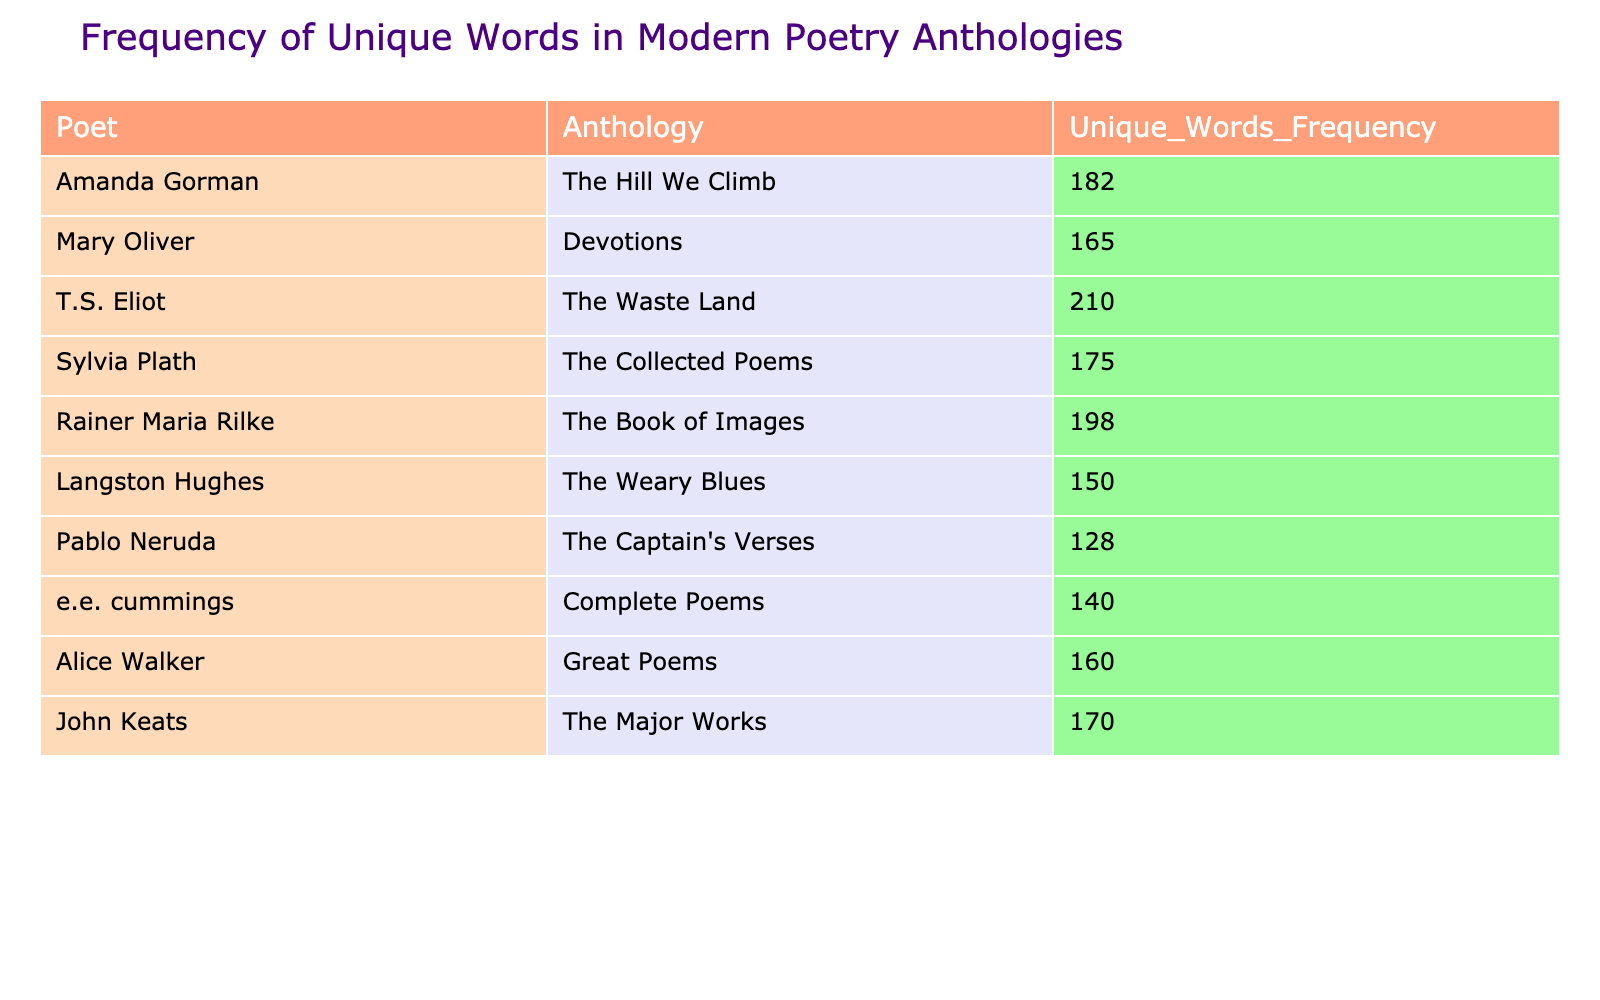What is the unique words frequency for Amanda Gorman? The table shows that the frequency of unique words for Amanda Gorman is listed directly under the column "Unique_Words_Frequency." According to the table, this value is 182.
Answer: 182 Which poet has the highest unique words frequency? By examining the unique words frequency values in the table, T.S. Eliot has the highest frequency, which is 210, compared to other poets listed.
Answer: 210 Is the unique words frequency for Pablo Neruda greater than 130? The table states that Pablo Neruda's unique words frequency is 128, which is less than 130. Therefore, the answer is no.
Answer: No What is the average unique words frequency for all the poets listed? To calculate the average frequency, sum the unique words frequencies for all poets: (182 + 165 + 210 + 175 + 198 + 150 + 128 + 140 + 160 + 170) = 1870. There are 10 poets, so the average is 1870 / 10 = 187.
Answer: 187 Which anthology has the lowest unique words frequency? By reviewing the values in the "Unique_Words_Frequency" column, the lowest frequency is 128, which corresponds to Pablo Neruda's anthology "The Captain's Verses."
Answer: The Captain's Verses How many poets have a unique words frequency greater than 170? Evaluating the table, the poets with frequencies greater than 170 are T.S. Eliot (210), Rainer Maria Rilke (198), Amanda Gorman (182), and Sylvia Plath (175). This makes a total of 4 poets.
Answer: 4 Is Mary Oliver’s unique words frequency equal to 165? The table shows Mary Oliver has a unique words frequency of 165, which matches the stated question. Thus, the answer is yes.
Answer: Yes What is the difference in unique words frequency between T.S. Eliot and Langston Hughes? To find this difference, subtract the unique words frequency of Langston Hughes (150) from T.S. Eliot's frequency (210): 210 - 150 = 60.
Answer: 60 